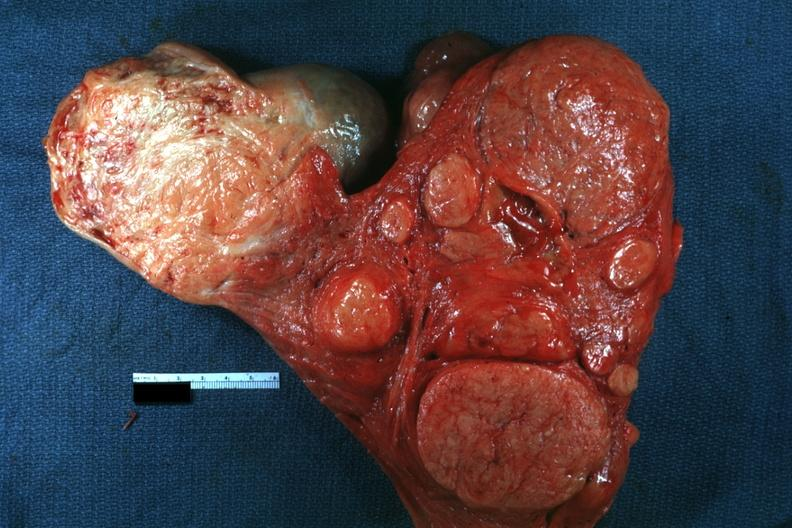s female reproductive present?
Answer the question using a single word or phrase. Yes 